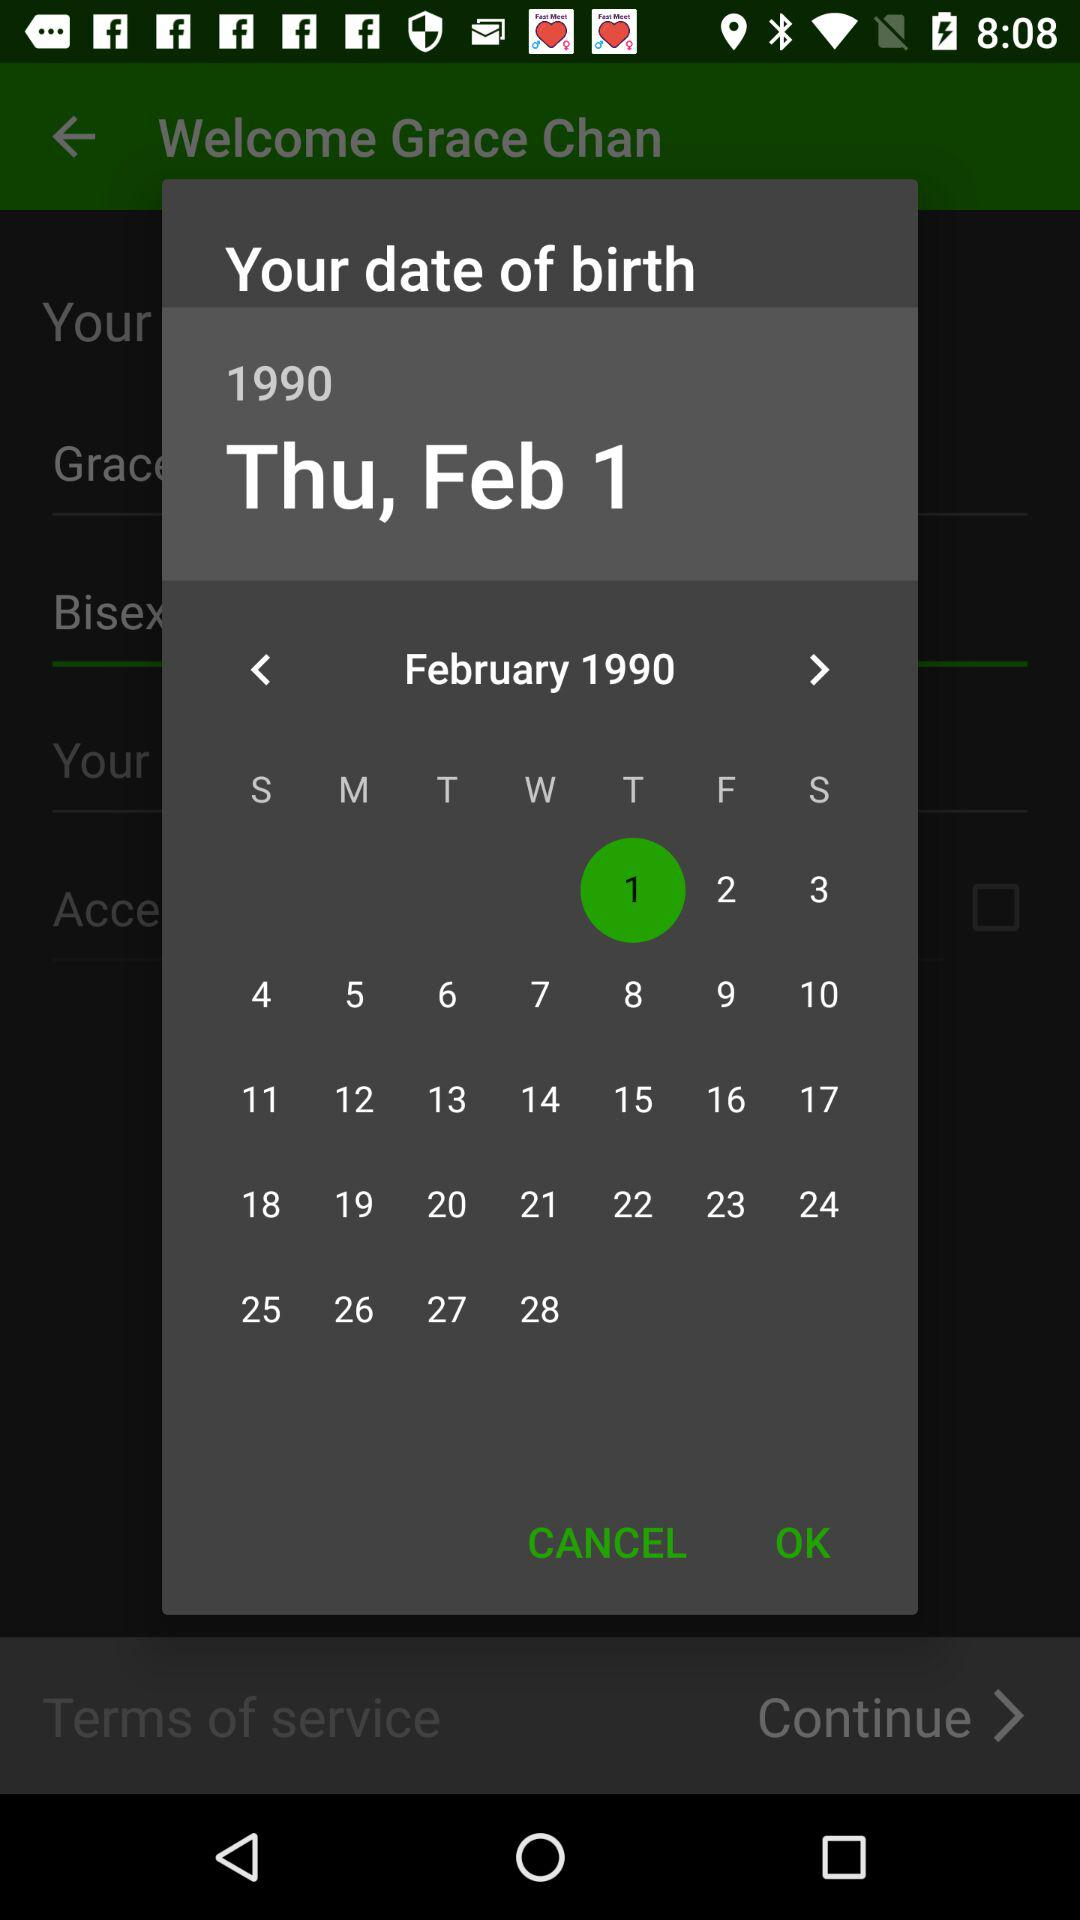How many months are available in the date picker?
Answer the question using a single word or phrase. 12 